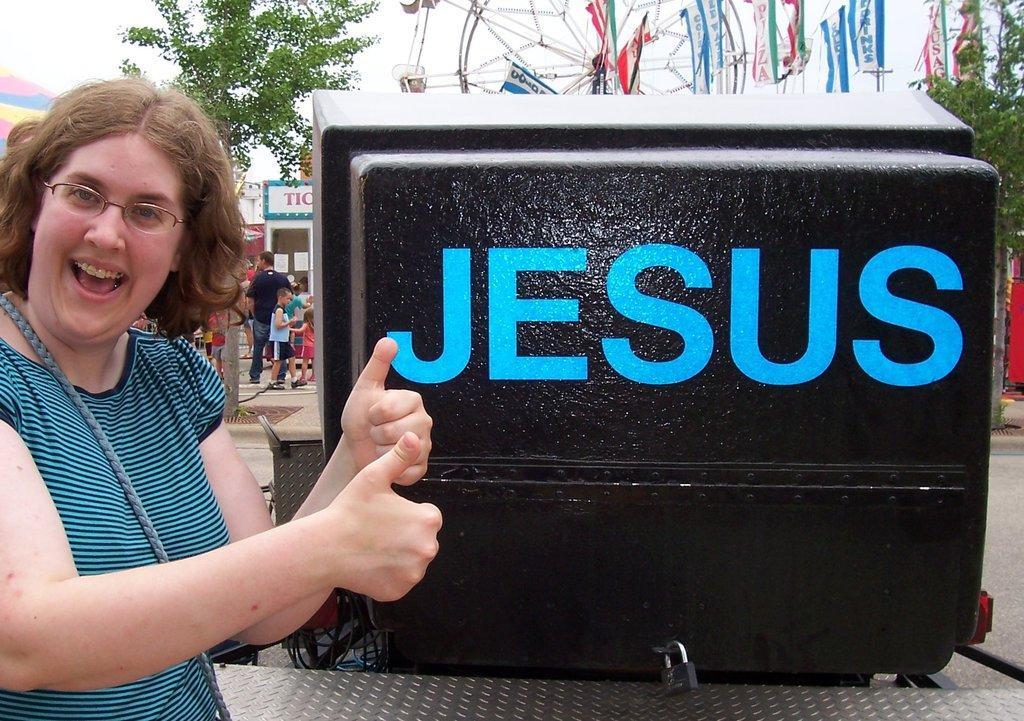In one or two sentences, can you explain what this image depicts? On the left side, there is a woman in a T-shirt, wearing a spectacle and showing both thumbs. On the right side, there is a blue color text on a black colored surface of an object. In the background, there are trees, flags, children, persons, shelters and there are clouds in the sky. 